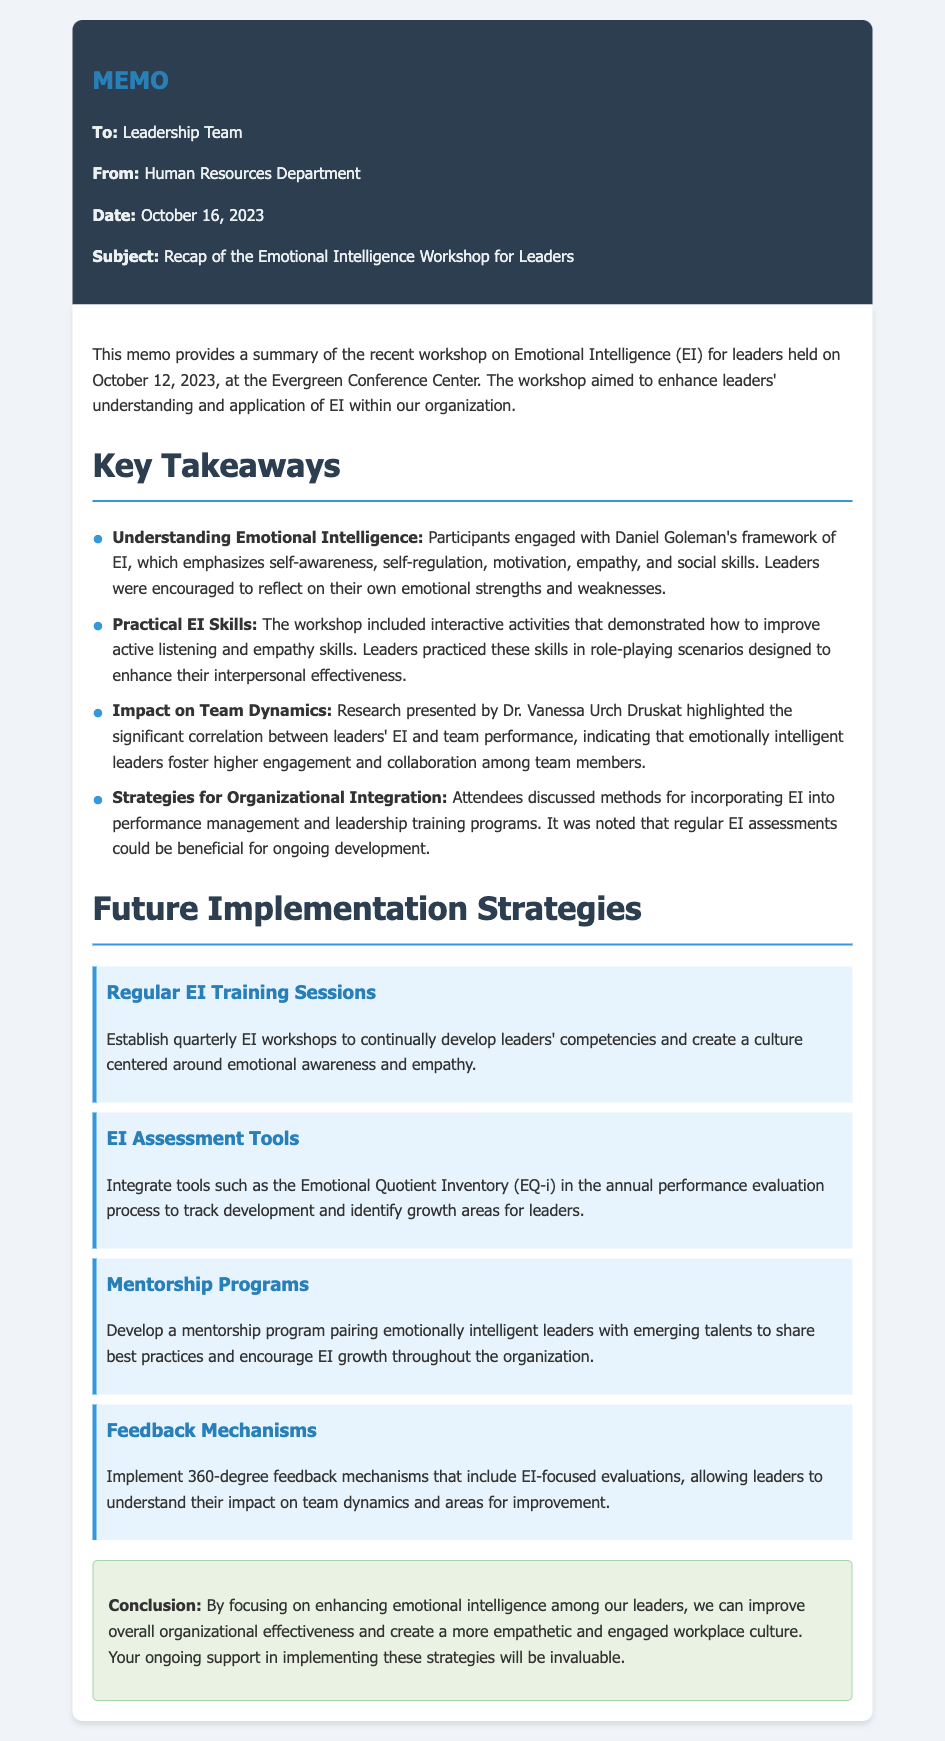What is the date of the workshop? The workshop was held on October 12, 2023.
Answer: October 12, 2023 Who presented the research on team dynamics? The research highlighting the correlation between leaders' EI and team performance was presented by Dr. Vanessa Urch Druskat.
Answer: Dr. Vanessa Urch Druskat What is one of the key components of Daniel Goleman's EI framework mentioned in the memo? One of the key components mentioned is self-awareness.
Answer: self-awareness How often are EI training sessions proposed to be held? The memo proposes establishing quarterly EI training sessions.
Answer: quarterly What is one method suggested to integrate EI into the leadership evaluation process? The integration of tools such as the Emotional Quotient Inventory (EQ-i) is suggested.
Answer: Emotional Quotient Inventory (EQ-i) What type of feedback mechanism is proposed in the document? A 360-degree feedback mechanism that includes EI-focused evaluations is proposed.
Answer: 360-degree feedback mechanism What is the overall goal stated in the conclusion of the memo? The goal is to improve overall organizational effectiveness and create a more empathetic and engaged workplace culture.
Answer: improve overall organizational effectiveness What is the main subject of this memo? The main subject of the memo is the recap of the Emotional Intelligence Workshop for Leaders.
Answer: Emotional Intelligence Workshop for Leaders 